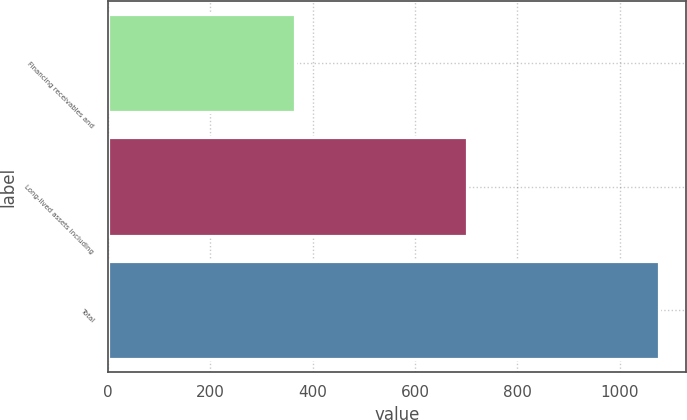Convert chart to OTSL. <chart><loc_0><loc_0><loc_500><loc_500><bar_chart><fcel>Financing receivables and<fcel>Long-lived assets including<fcel>Total<nl><fcel>366<fcel>702<fcel>1076<nl></chart> 